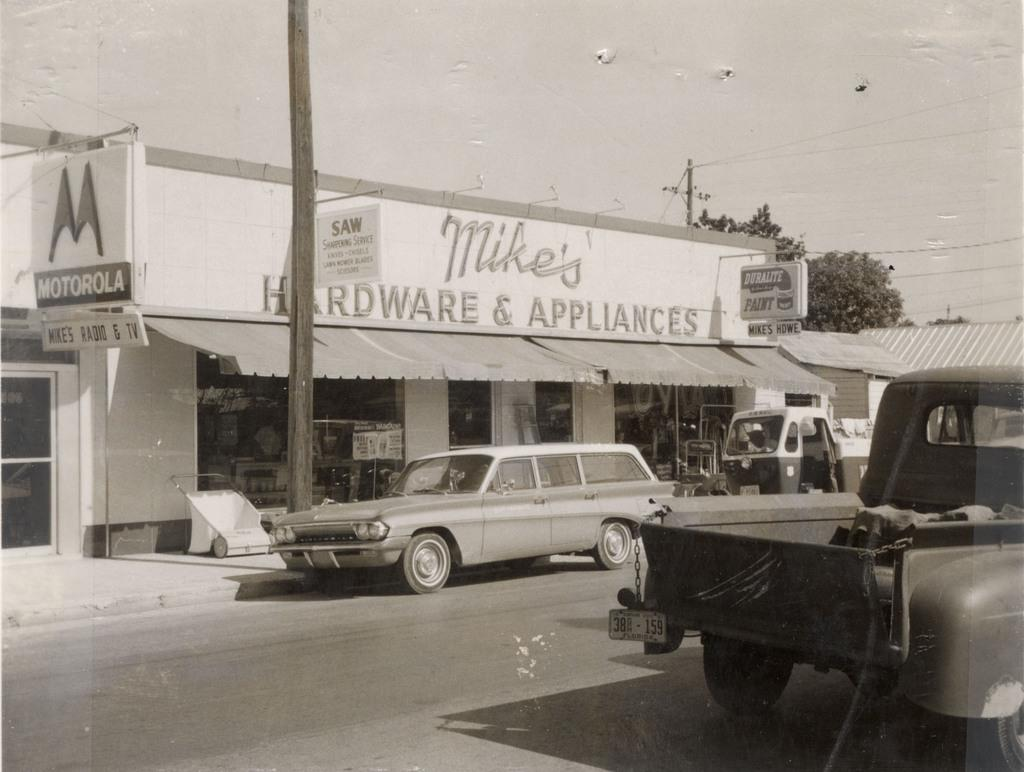What can be seen on the road in the image? There are vehicles on the road in the image. What structure is present in the image? There is a platform in the image. What is used to provide shade in the image? There is a sunshade in the image. What type of signage is visible in the image? There are banners in the image. What type of vegetation is present in the image? There are trees in the image. What is visible in the background of the image? The sky is visible in the background of the image. What type of screw is being used to hold the banner in the image? There is no screw visible in the image; the banners are attached to the platform or other structures. 